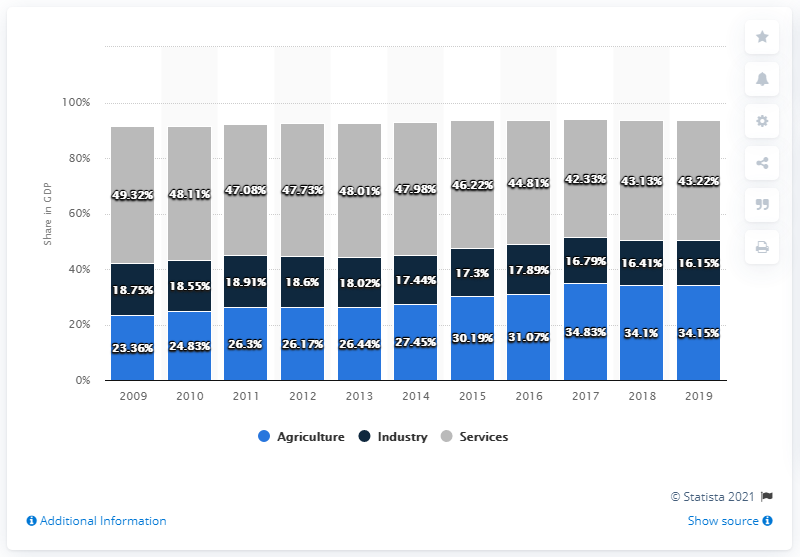Give some essential details in this illustration. In 2019, the agriculture sector comprised 34.15% of Kenya's gross domestic product. In 2019, the services sector accounted for 43.22% of Kenya's Gross Domestic Product (GDP). In 2019, industry contributed 16.15% of Kenya's Gross Domestic Product. 